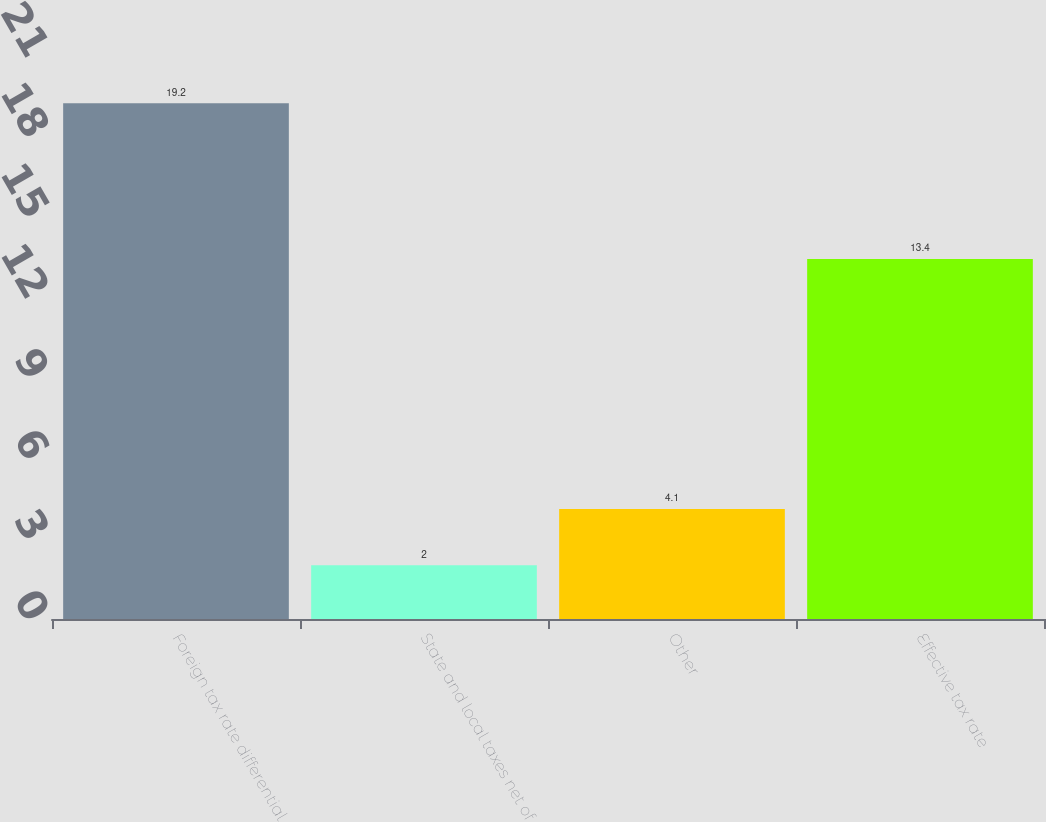Convert chart to OTSL. <chart><loc_0><loc_0><loc_500><loc_500><bar_chart><fcel>Foreign tax rate differential<fcel>State and local taxes net of<fcel>Other<fcel>Effective tax rate<nl><fcel>19.2<fcel>2<fcel>4.1<fcel>13.4<nl></chart> 